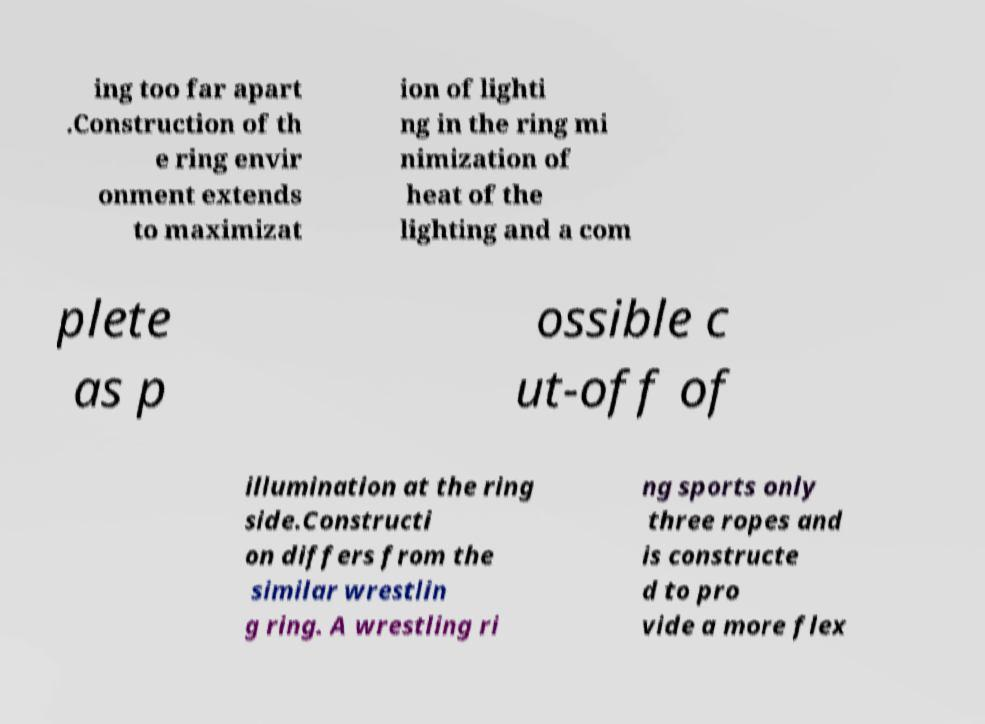Can you read and provide the text displayed in the image?This photo seems to have some interesting text. Can you extract and type it out for me? ing too far apart .Construction of th e ring envir onment extends to maximizat ion of lighti ng in the ring mi nimization of heat of the lighting and a com plete as p ossible c ut-off of illumination at the ring side.Constructi on differs from the similar wrestlin g ring. A wrestling ri ng sports only three ropes and is constructe d to pro vide a more flex 